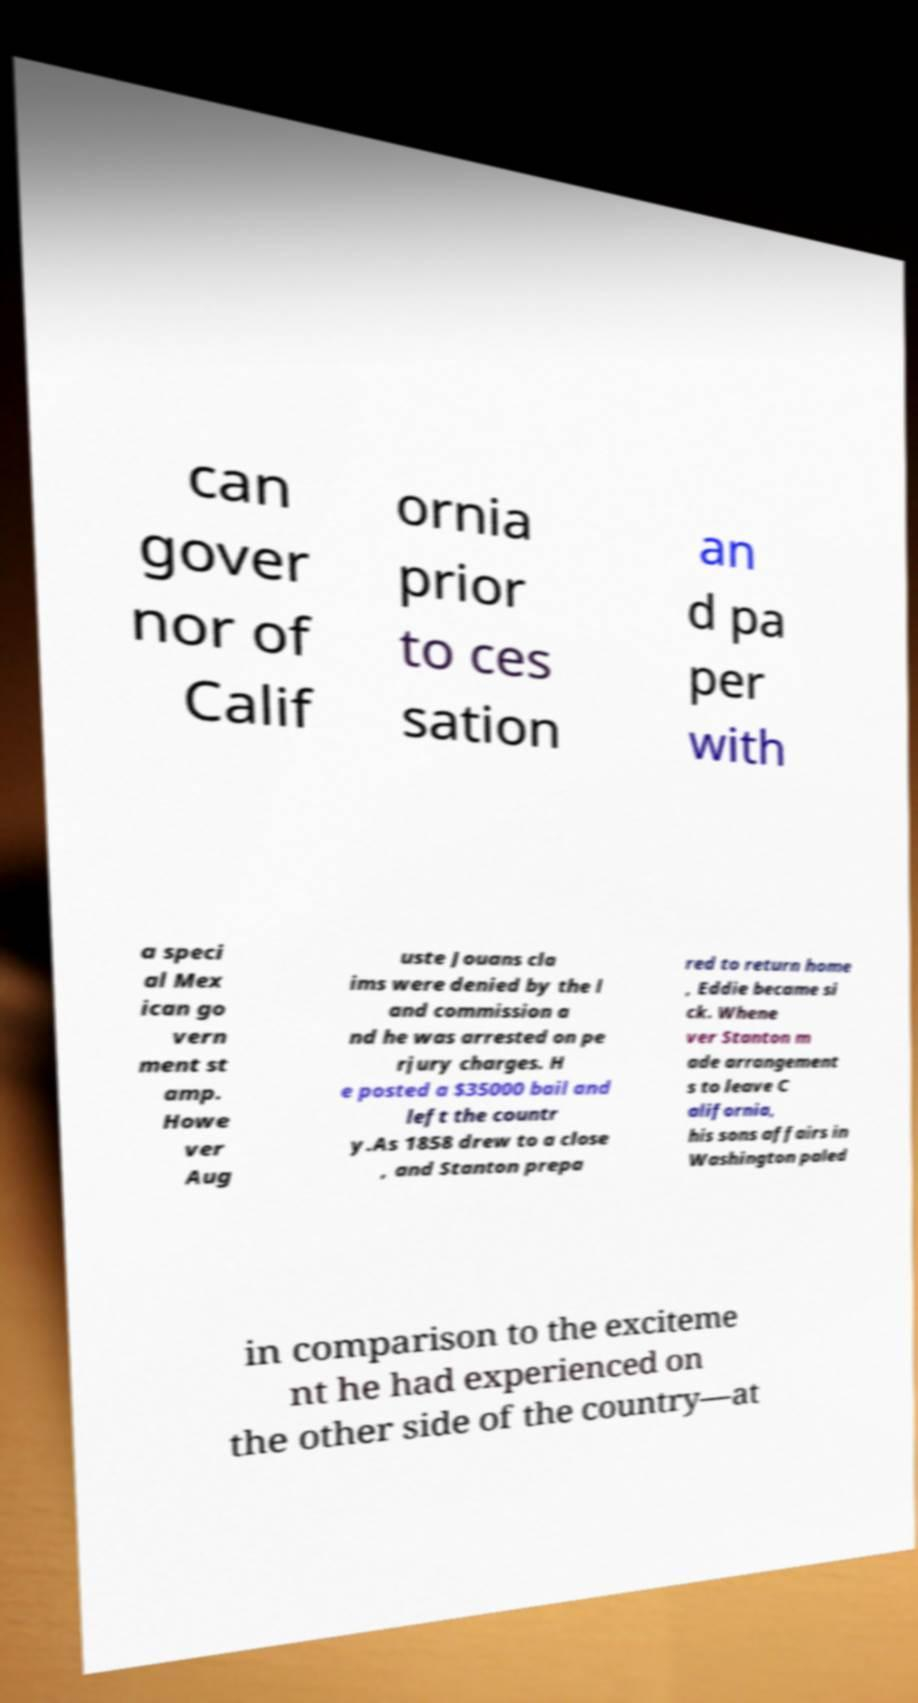What messages or text are displayed in this image? I need them in a readable, typed format. can gover nor of Calif ornia prior to ces sation an d pa per with a speci al Mex ican go vern ment st amp. Howe ver Aug uste Jouans cla ims were denied by the l and commission a nd he was arrested on pe rjury charges. H e posted a $35000 bail and left the countr y.As 1858 drew to a close , and Stanton prepa red to return home , Eddie became si ck. Whene ver Stanton m ade arrangement s to leave C alifornia, his sons affairs in Washington paled in comparison to the exciteme nt he had experienced on the other side of the country—at 